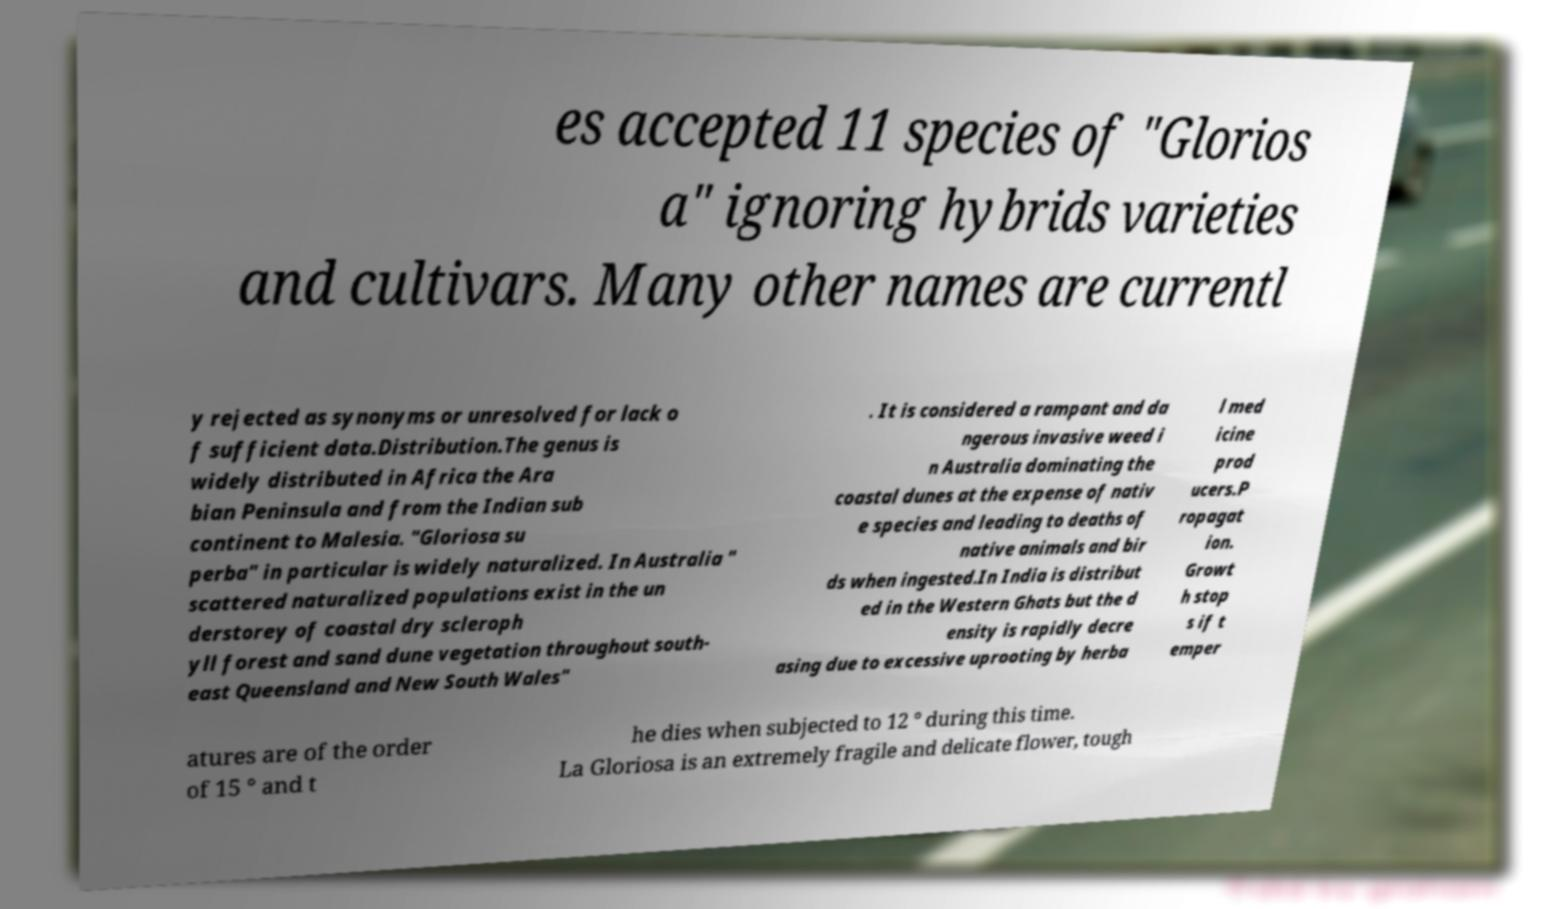Can you accurately transcribe the text from the provided image for me? es accepted 11 species of "Glorios a" ignoring hybrids varieties and cultivars. Many other names are currentl y rejected as synonyms or unresolved for lack o f sufficient data.Distribution.The genus is widely distributed in Africa the Ara bian Peninsula and from the Indian sub continent to Malesia. "Gloriosa su perba" in particular is widely naturalized. In Australia " scattered naturalized populations exist in the un derstorey of coastal dry scleroph yll forest and sand dune vegetation throughout south- east Queensland and New South Wales" . It is considered a rampant and da ngerous invasive weed i n Australia dominating the coastal dunes at the expense of nativ e species and leading to deaths of native animals and bir ds when ingested.In India is distribut ed in the Western Ghats but the d ensity is rapidly decre asing due to excessive uprooting by herba l med icine prod ucers.P ropagat ion. Growt h stop s if t emper atures are of the order of 15 ° and t he dies when subjected to 12 ° during this time. La Gloriosa is an extremely fragile and delicate flower, tough 